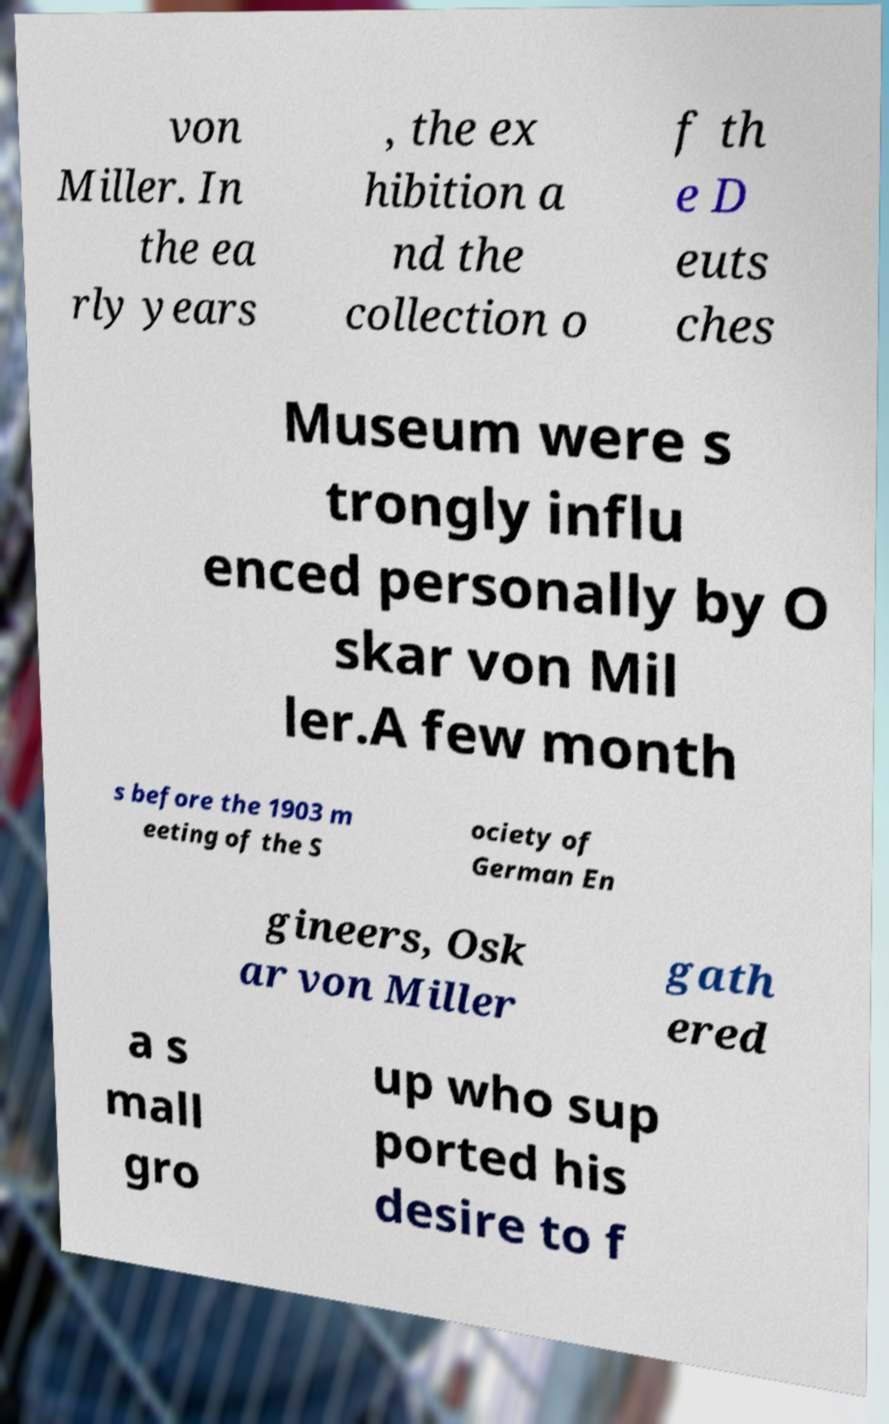Please read and relay the text visible in this image. What does it say? von Miller. In the ea rly years , the ex hibition a nd the collection o f th e D euts ches Museum were s trongly influ enced personally by O skar von Mil ler.A few month s before the 1903 m eeting of the S ociety of German En gineers, Osk ar von Miller gath ered a s mall gro up who sup ported his desire to f 